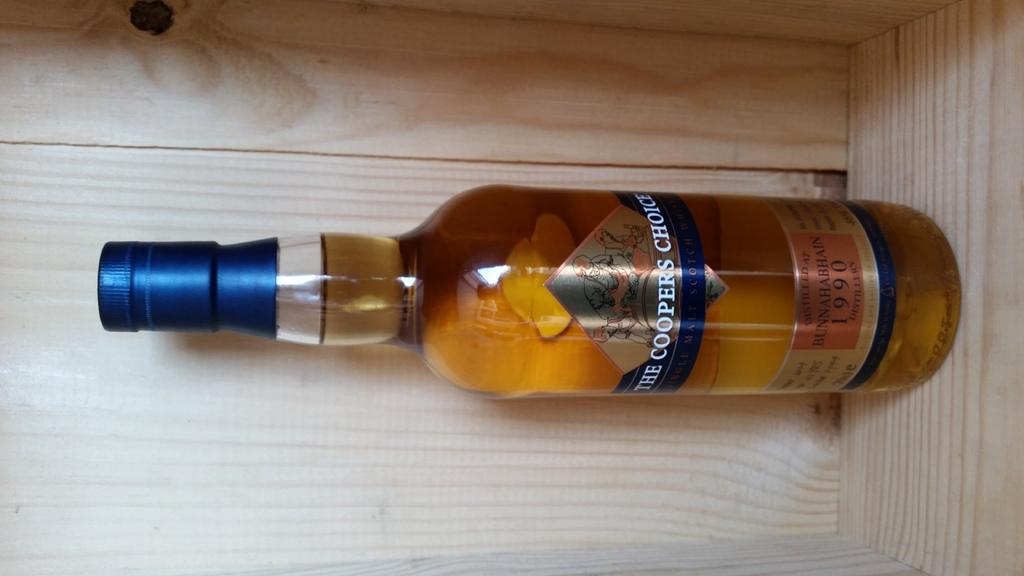Provide a one-sentence caption for the provided image. A bottle of The Cooper's Choice whiskey is on a wooden shelf. 